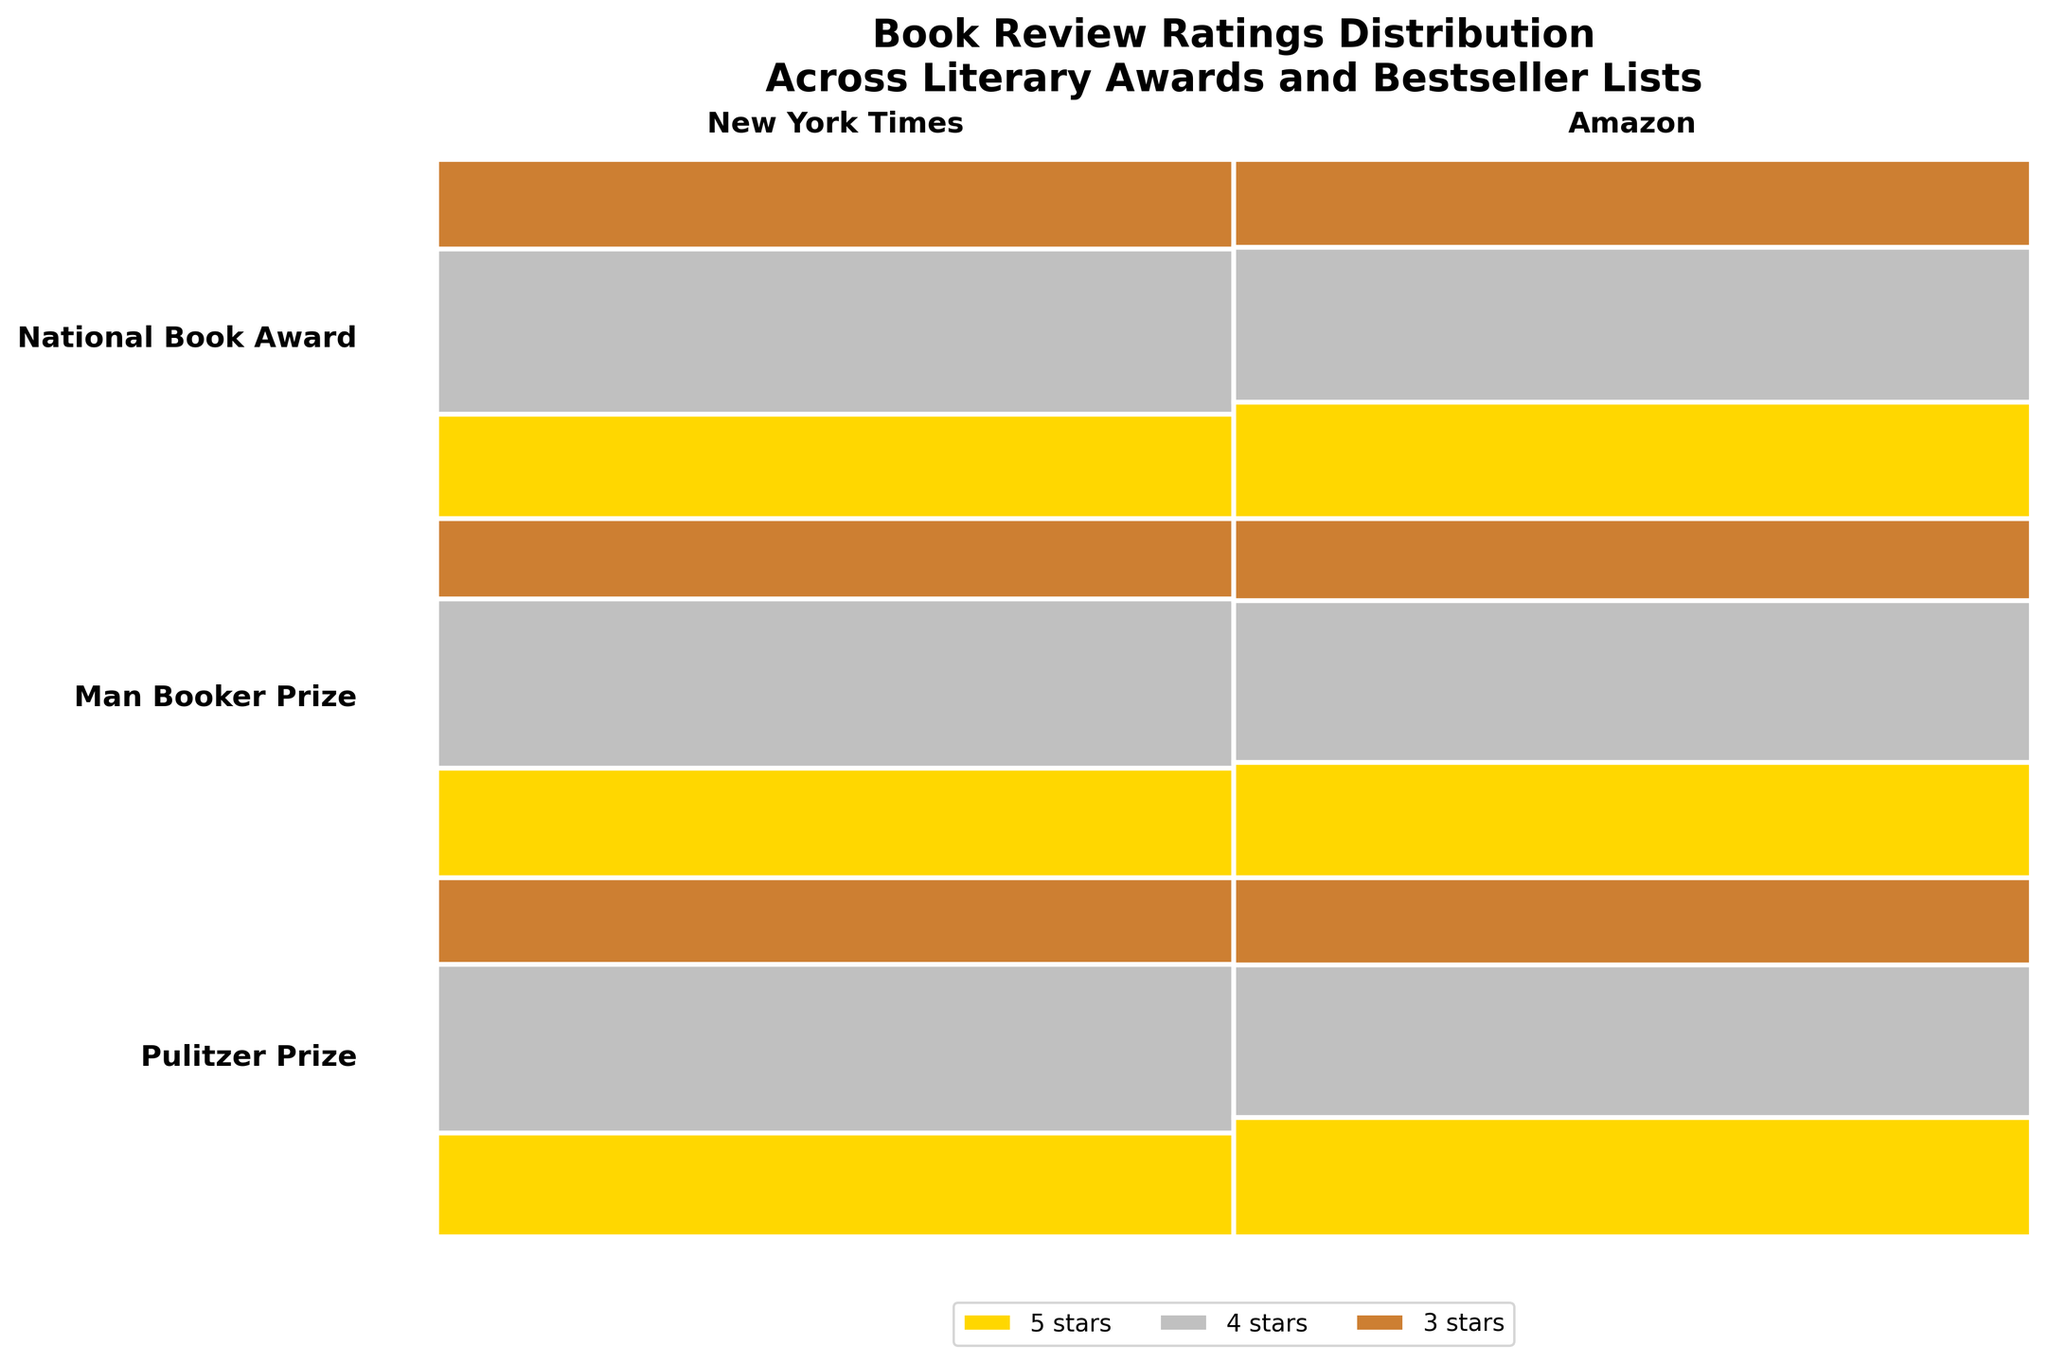What is the title of the figure? The title of the figure is a visible part of the chart, usually found at the top, summarizing the content or purpose of the figure.
Answer: Book Review Ratings Distribution Across Literary Awards and Bestseller Lists Which literary award has the largest percentage of 5-star ratings on the New York Times bestseller list? To determine this, observe the heights of the 5-star rating segments for each award within the New York Times column. The award with the largest segment has the highest percentage.
Answer: Pulitzer Prize Which has a higher overall proportion of 5-star ratings, Pulitzer Prize books on the New York Times list or Man Booker Prize books on Amazon? Compare the relative heights of the 5-star segments for these two categories: Pulitzer Prize on the New York Times and Man Booker Prize on Amazon.
Answer: Man Booker Prize on Amazon Are there any categories where the percentage of 4-star ratings is higher than the percentage of 3-star and 5-star ratings combined? Identify sections where the proportion of the 4-star segment exceeds the sum of the 3-star and 5-star segments.
Answer: No What is the color of the 3-star rating in the plot? The legend at the bottom of the plot indicates the color associated with each rating.
Answer: Bronze Which bestseller list shows a higher percentage of 5-star reviews for National Book Award winners? Compare the height of the 5-star segments for the National Book Award between the New York Times and Amazon columns.
Answer: Amazon Which rating category occupies the least vertical space overall for Pulitzer Prize winners? Sum up the heights of the segments for all ratings of Pulitzer Prize books, and identify the rating with the least total height.
Answer: 3 stars For which literary award and bestseller list is the percentage of 3-star ratings the smallest? Look for the shortest 3-star segments across all combinations. The one with the smallest vertical space represents the smallest percentage.
Answer: Man Booker Prize, New York Times How many literary awards are represented in the plot? Each unique label on the vertical axis represents a different literary award. Count these labels.
Answer: 3 